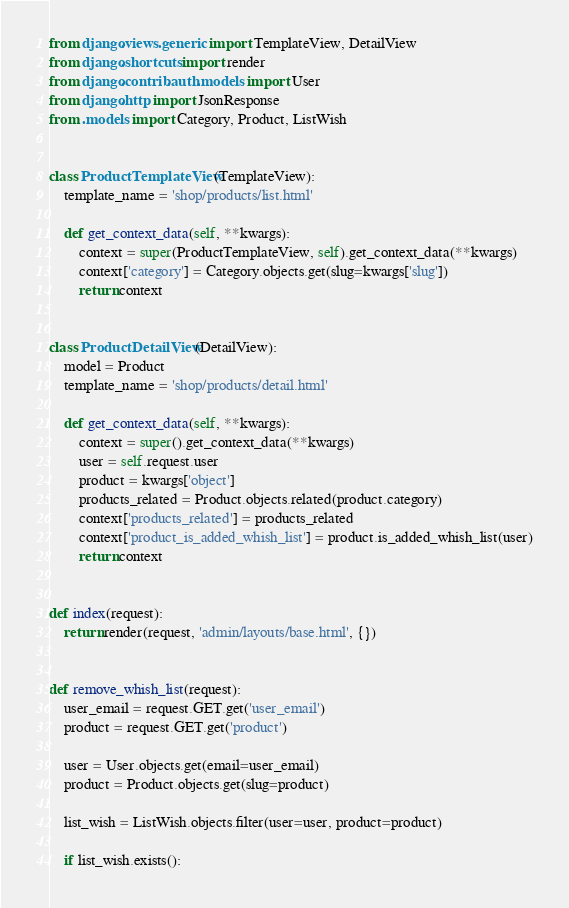Convert code to text. <code><loc_0><loc_0><loc_500><loc_500><_Python_>from django.views.generic import TemplateView, DetailView
from django.shortcuts import render
from django.contrib.auth.models import User
from django.http import JsonResponse
from .models import Category, Product, ListWish


class ProductTemplateView(TemplateView):
    template_name = 'shop/products/list.html'

    def get_context_data(self, **kwargs):
        context = super(ProductTemplateView, self).get_context_data(**kwargs)
        context['category'] = Category.objects.get(slug=kwargs['slug'])
        return context


class ProductDetailView(DetailView):
    model = Product
    template_name = 'shop/products/detail.html'

    def get_context_data(self, **kwargs):
        context = super().get_context_data(**kwargs)
        user = self.request.user
        product = kwargs['object']
        products_related = Product.objects.related(product.category)
        context['products_related'] = products_related
        context['product_is_added_whish_list'] = product.is_added_whish_list(user)
        return context


def index(request):
    return render(request, 'admin/layouts/base.html', {})


def remove_whish_list(request):
    user_email = request.GET.get('user_email')
    product = request.GET.get('product')

    user = User.objects.get(email=user_email)
    product = Product.objects.get(slug=product)

    list_wish = ListWish.objects.filter(user=user, product=product)

    if list_wish.exists():</code> 